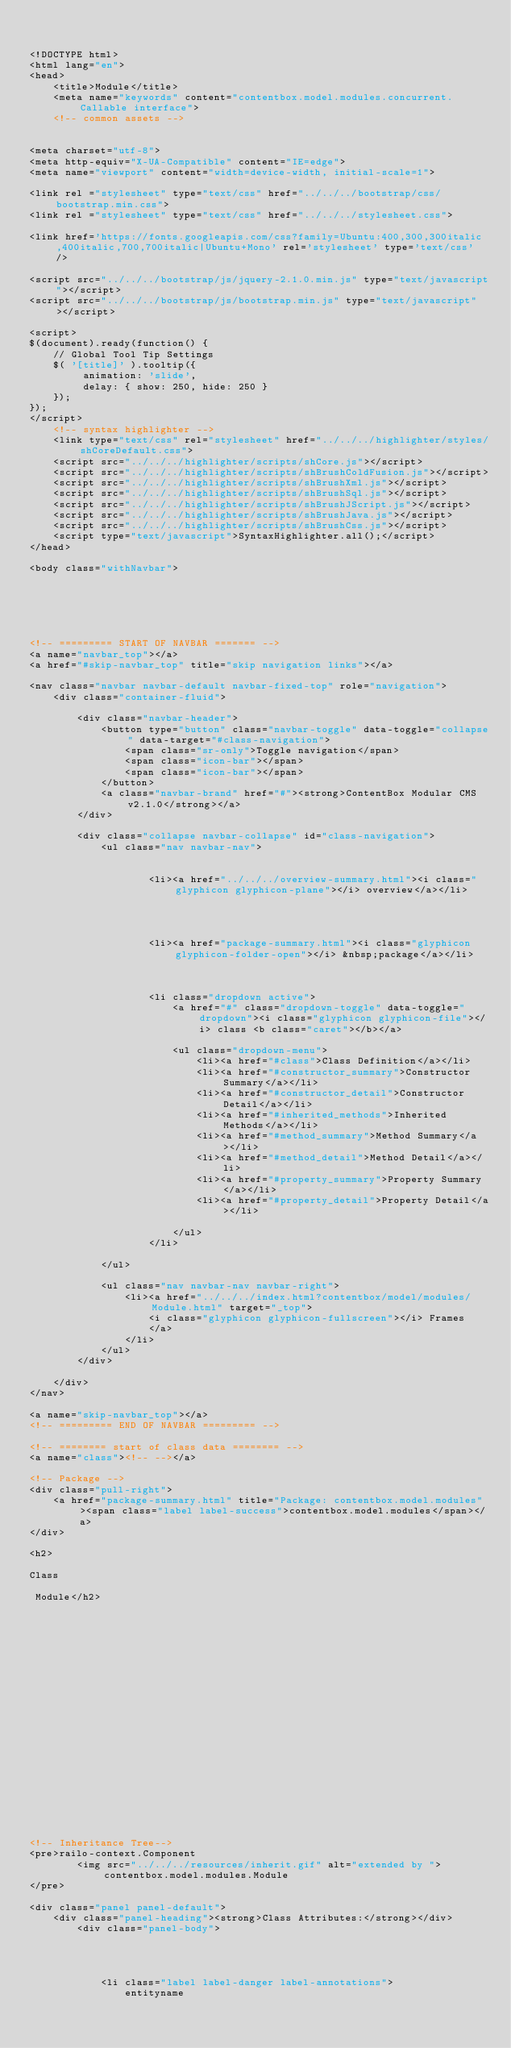<code> <loc_0><loc_0><loc_500><loc_500><_HTML_>

<!DOCTYPE html>
<html lang="en">
<head>
	<title>Module</title>
	<meta name="keywords" content="contentbox.model.modules.concurrent.Callable interface">
	<!-- common assets -->
	

<meta charset="utf-8">
<meta http-equiv="X-UA-Compatible" content="IE=edge">
<meta name="viewport" content="width=device-width, initial-scale=1">

<link rel ="stylesheet" type="text/css" href="../../../bootstrap/css/bootstrap.min.css">
<link rel ="stylesheet" type="text/css" href="../../../stylesheet.css">
	
<link href='https://fonts.googleapis.com/css?family=Ubuntu:400,300,300italic,400italic,700,700italic|Ubuntu+Mono' rel='stylesheet' type='text/css' />
	
<script src="../../../bootstrap/js/jquery-2.1.0.min.js" type="text/javascript"></script>
<script src="../../../bootstrap/js/bootstrap.min.js" type="text/javascript"></script>

<script>
$(document).ready(function() {
	// Global Tool Tip Settings
	$( '[title]' ).tooltip({
		 animation: 'slide',
		 delay: { show: 250, hide: 250 }
	});
});
</script>
	<!-- syntax highlighter -->
	<link type="text/css" rel="stylesheet" href="../../../highlighter/styles/shCoreDefault.css">
	<script src="../../../highlighter/scripts/shCore.js"></script>
	<script src="../../../highlighter/scripts/shBrushColdFusion.js"></script>
	<script src="../../../highlighter/scripts/shBrushXml.js"></script>
	<script src="../../../highlighter/scripts/shBrushSql.js"></script>
	<script src="../../../highlighter/scripts/shBrushJScript.js"></script>
	<script src="../../../highlighter/scripts/shBrushJava.js"></script>
	<script src="../../../highlighter/scripts/shBrushCss.js"></script>
	<script type="text/javascript">SyntaxHighlighter.all();</script>
</head>

<body class="withNavbar">






<!-- ========= START OF NAVBAR ======= -->
<a name="navbar_top"></a>
<a href="#skip-navbar_top" title="skip navigation links"></a>	

<nav class="navbar navbar-default navbar-fixed-top" role="navigation">
	<div class="container-fluid">
    
		<div class="navbar-header">
			<button type="button" class="navbar-toggle" data-toggle="collapse" data-target="#class-navigation">
				<span class="sr-only">Toggle navigation</span>
				<span class="icon-bar"></span>
				<span class="icon-bar"></span>
			</button>
			<a class="navbar-brand" href="#"><strong>ContentBox Modular CMS v2.1.0</strong></a>
		</div>

	    <div class="collapse navbar-collapse" id="class-navigation">
	    	<ul class="nav navbar-nav">
				
					
					<li><a href="../../../overview-summary.html"><i class="glyphicon glyphicon-plane"></i> overview</a></li>
					
				

				
					<li><a href="package-summary.html"><i class="glyphicon glyphicon-folder-open"></i> &nbsp;package</a></li>
				

			  	
					<li class="dropdown active">
						<a href="#" class="dropdown-toggle" data-toggle="dropdown"><i class="glyphicon glyphicon-file"></i> class <b class="caret"></b></a>

						<ul class="dropdown-menu">
							<li><a href="#class">Class Definition</a></li>
							<li><a href="#constructor_summary">Constructor Summary</a></li>
							<li><a href="#constructor_detail">Constructor Detail</a></li>
							<li><a href="#inherited_methods">Inherited Methods</a></li>
							<li><a href="#method_summary">Method Summary</a></li>
							<li><a href="#method_detail">Method Detail</a></li>
							<li><a href="#property_summary">Property Summary</a></li>
							<li><a href="#property_detail">Property Detail</a></li>
							
						</ul>
					</li>
				
	      	</ul>

			<ul class="nav navbar-nav navbar-right">
				<li><a href="../../../index.html?contentbox/model/modules/Module.html" target="_top">
					<i class="glyphicon glyphicon-fullscreen"></i> Frames
					</a>
				</li>
			</ul>
	    </div>

	</div>
</nav>	

<a name="skip-navbar_top"></a>
<!-- ========= END OF NAVBAR ========= -->

<!-- ======== start of class data ======== -->
<a name="class"><!-- --></a>

<!-- Package -->
<div class="pull-right">
	<a href="package-summary.html" title="Package: contentbox.model.modules"><span class="label label-success">contentbox.model.modules</span></a>
</div>

<h2>

Class

 Module</h2>








	
		
	
	

	
		
		
			
		
	
	


<!-- Inheritance Tree-->
<pre>railo-context.Component
        <img src="../../../resources/inherit.gif" alt="extended by ">contentbox.model.modules.Module
</pre>

<div class="panel panel-default">
	<div class="panel-heading"><strong>Class Attributes:</strong></div>
		<div class="panel-body">
		
		
			
			
			<li class="label label-danger label-annotations">
				entityname </code> 